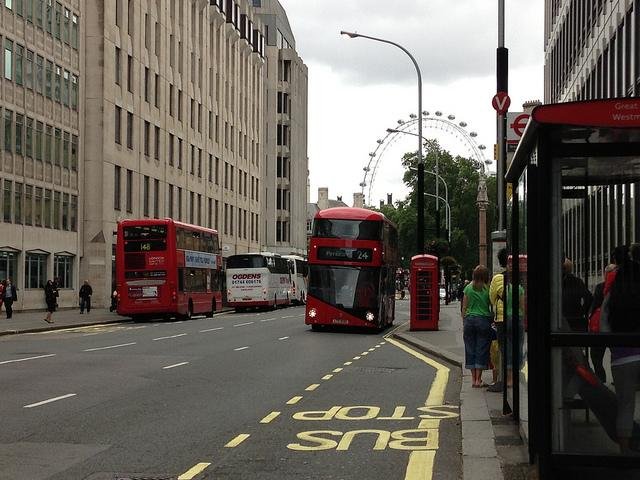What company owns vehicles similar to the ones in the street? Please explain your reasoning. greyhound. Greyhound is a bus company. 